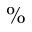<formula> <loc_0><loc_0><loc_500><loc_500>\%</formula> 